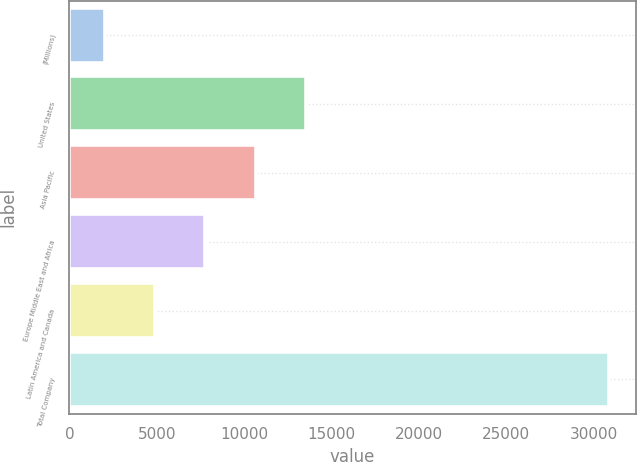Convert chart. <chart><loc_0><loc_0><loc_500><loc_500><bar_chart><fcel>(Millions)<fcel>United States<fcel>Asia Pacific<fcel>Europe Middle East and Africa<fcel>Latin America and Canada<fcel>Total Company<nl><fcel>2013<fcel>13556.2<fcel>10670.4<fcel>7784.6<fcel>4898.8<fcel>30871<nl></chart> 